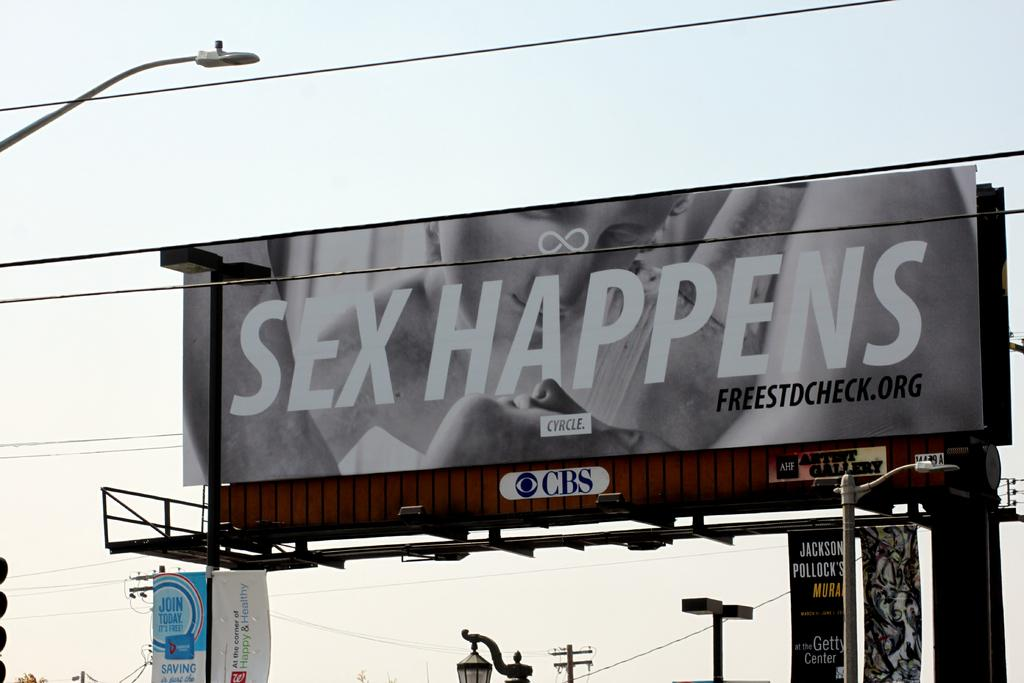<image>
Write a terse but informative summary of the picture. a billboard that says 'sex happens' on it 